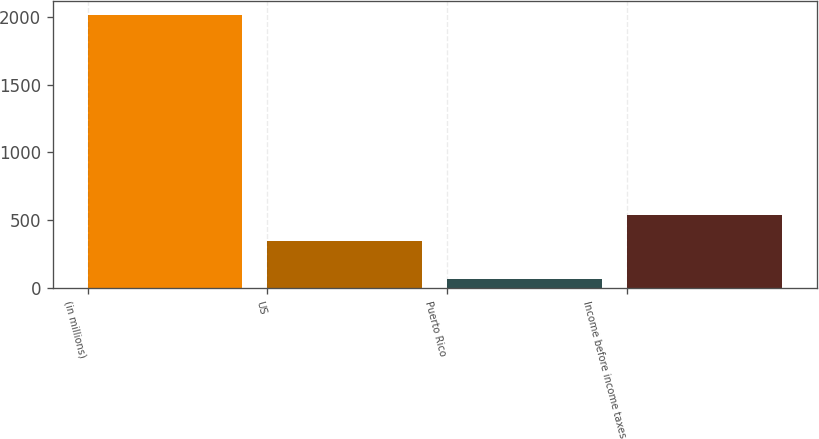Convert chart to OTSL. <chart><loc_0><loc_0><loc_500><loc_500><bar_chart><fcel>(in millions)<fcel>US<fcel>Puerto Rico<fcel>Income before income taxes<nl><fcel>2014<fcel>347<fcel>66<fcel>541.8<nl></chart> 